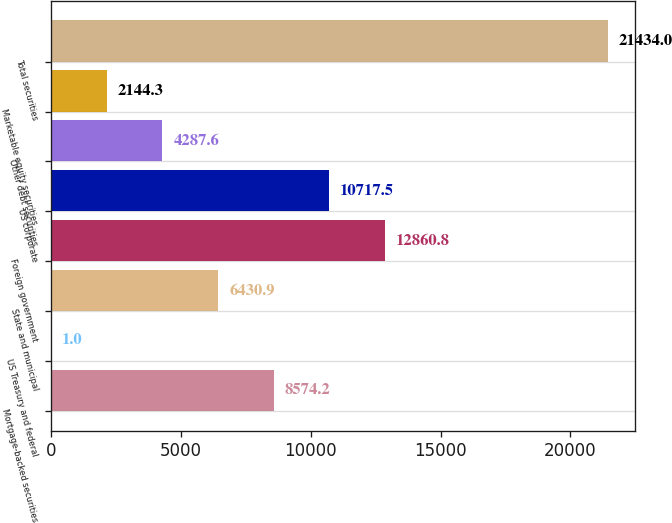Convert chart to OTSL. <chart><loc_0><loc_0><loc_500><loc_500><bar_chart><fcel>Mortgage-backed securities<fcel>US Treasury and federal<fcel>State and municipal<fcel>Foreign government<fcel>US corporate<fcel>Other debt securities<fcel>Marketable equity securities<fcel>Total securities<nl><fcel>8574.2<fcel>1<fcel>6430.9<fcel>12860.8<fcel>10717.5<fcel>4287.6<fcel>2144.3<fcel>21434<nl></chart> 